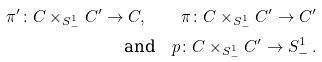<formula> <loc_0><loc_0><loc_500><loc_500>\pi ^ { \prime } \colon C \times _ { S ^ { 1 } _ { - } } C ^ { \prime } \to C , \quad \pi \colon C \times _ { S ^ { 1 } _ { - } } C ^ { \prime } \to C ^ { \prime } \\ \text {and} \quad p \colon C \times _ { S ^ { 1 } _ { - } } C ^ { \prime } \to S ^ { 1 } _ { - } \, .</formula> 